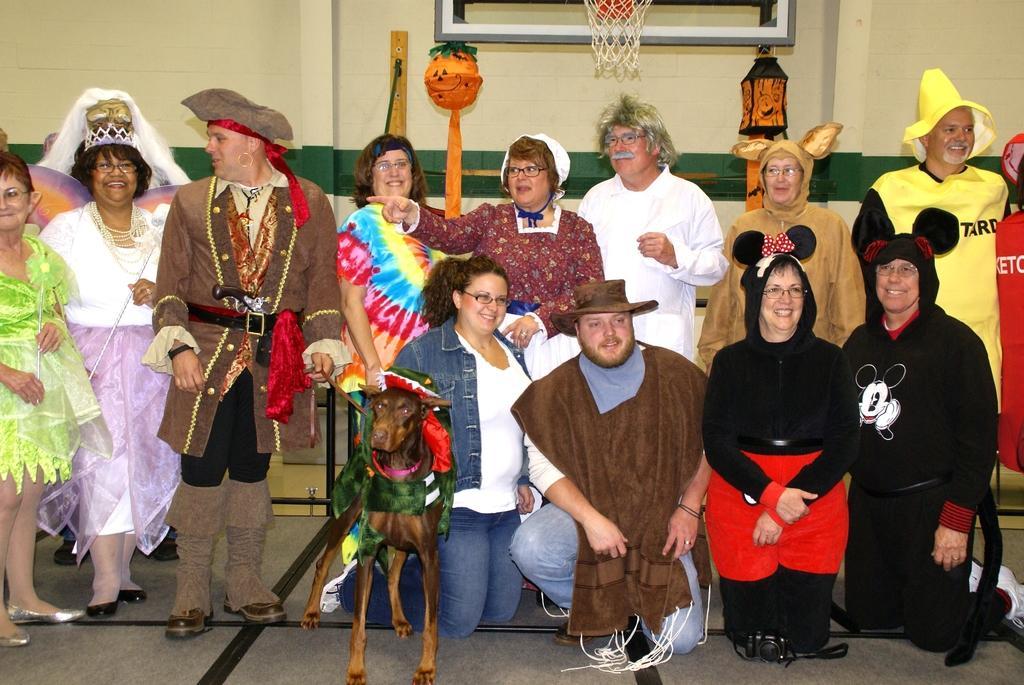How would you summarize this image in a sentence or two? The picture consist of there is a big room many people are there on the room and some people they are sitting on the floor and some people they are standing on the floor and behind the persons the basketball coat is there and in front of the people some dog is standing on the floor any of people they are laughing and the back ground is white. 